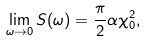Convert formula to latex. <formula><loc_0><loc_0><loc_500><loc_500>\lim _ { \omega \to 0 } S ( \omega ) = \frac { \pi } { 2 } \alpha \chi _ { 0 } ^ { 2 } ,</formula> 